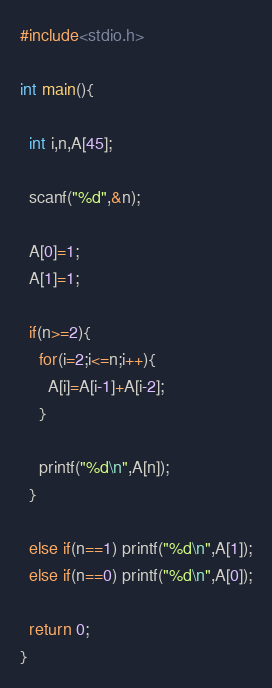<code> <loc_0><loc_0><loc_500><loc_500><_C_>#include<stdio.h>

int main(){

  int i,n,A[45];

  scanf("%d",&n);

  A[0]=1;
  A[1]=1;

  if(n>=2){
    for(i=2;i<=n;i++){
      A[i]=A[i-1]+A[i-2];
    }

    printf("%d\n",A[n]);
  }

  else if(n==1) printf("%d\n",A[1]);
  else if(n==0) printf("%d\n",A[0]);
  
  return 0;
}

</code> 